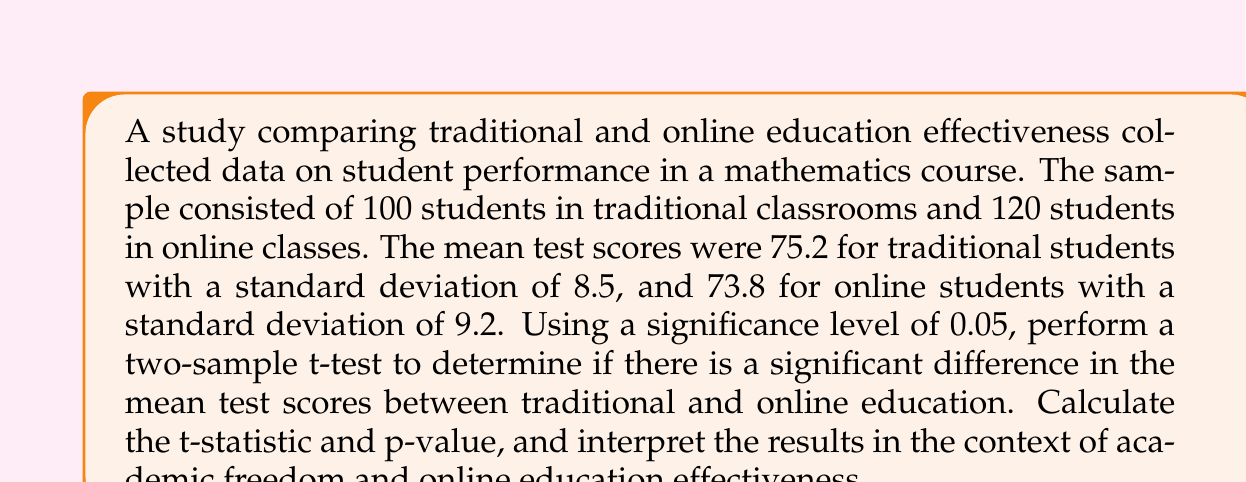Show me your answer to this math problem. To compare the effectiveness of traditional and online education, we'll use a two-sample t-test. Let's follow these steps:

1. Define the null and alternative hypotheses:
   $H_0: \mu_1 - \mu_2 = 0$ (no difference in means)
   $H_a: \mu_1 - \mu_2 \neq 0$ (there is a difference in means)

2. Calculate the pooled standard error:
   $SE = \sqrt{\frac{s_1^2}{n_1} + \frac{s_2^2}{n_2}}$
   $SE = \sqrt{\frac{8.5^2}{100} + \frac{9.2^2}{120}} = \sqrt{0.7225 + 0.7053} = \sqrt{1.4278} = 1.1949$

3. Calculate the t-statistic:
   $t = \frac{\bar{x_1} - \bar{x_2}}{SE} = \frac{75.2 - 73.8}{1.1949} = \frac{1.4}{1.1949} = 1.1716$

4. Determine the degrees of freedom:
   $df = n_1 + n_2 - 2 = 100 + 120 - 2 = 218$

5. Find the critical t-value for a two-tailed test at α = 0.05 and df = 218:
   $t_{critical} = \pm 1.9711$

6. Calculate the p-value:
   Using a t-distribution calculator or table, we find:
   $p-value = 2 * P(T > |1.1716|) = 0.2426$

7. Interpret the results:
   Since $|t| = 1.1716 < t_{critical} = 1.9711$ and $p-value = 0.2426 > \alpha = 0.05$, we fail to reject the null hypothesis.

There is not enough evidence to conclude that there is a significant difference in the mean test scores between traditional and online education at the 0.05 significance level.

This result suggests that online education may be as effective as traditional education in this context, which could have implications for academic freedom and the potential of online education. However, further research with larger sample sizes and consideration of other factors would be necessary to draw more definitive conclusions.
Answer: $t = 1.1716$, $p-value = 0.2426$. Fail to reject $H_0$; no significant difference in mean test scores. 